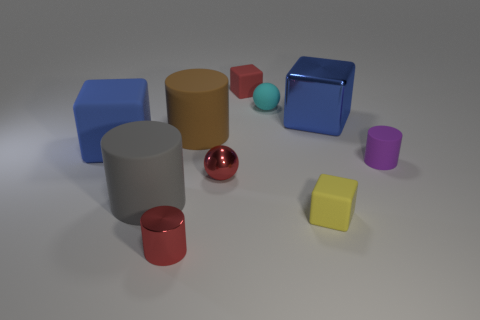Subtract all small purple cylinders. How many cylinders are left? 3 Subtract all cylinders. How many objects are left? 6 Subtract all brown cylinders. How many cylinders are left? 3 Add 9 large brown cylinders. How many large brown cylinders exist? 10 Subtract 1 red cubes. How many objects are left? 9 Subtract 2 cylinders. How many cylinders are left? 2 Subtract all cyan spheres. Subtract all cyan blocks. How many spheres are left? 1 Subtract all brown balls. How many blue blocks are left? 2 Subtract all small purple objects. Subtract all small purple cylinders. How many objects are left? 8 Add 3 red rubber objects. How many red rubber objects are left? 4 